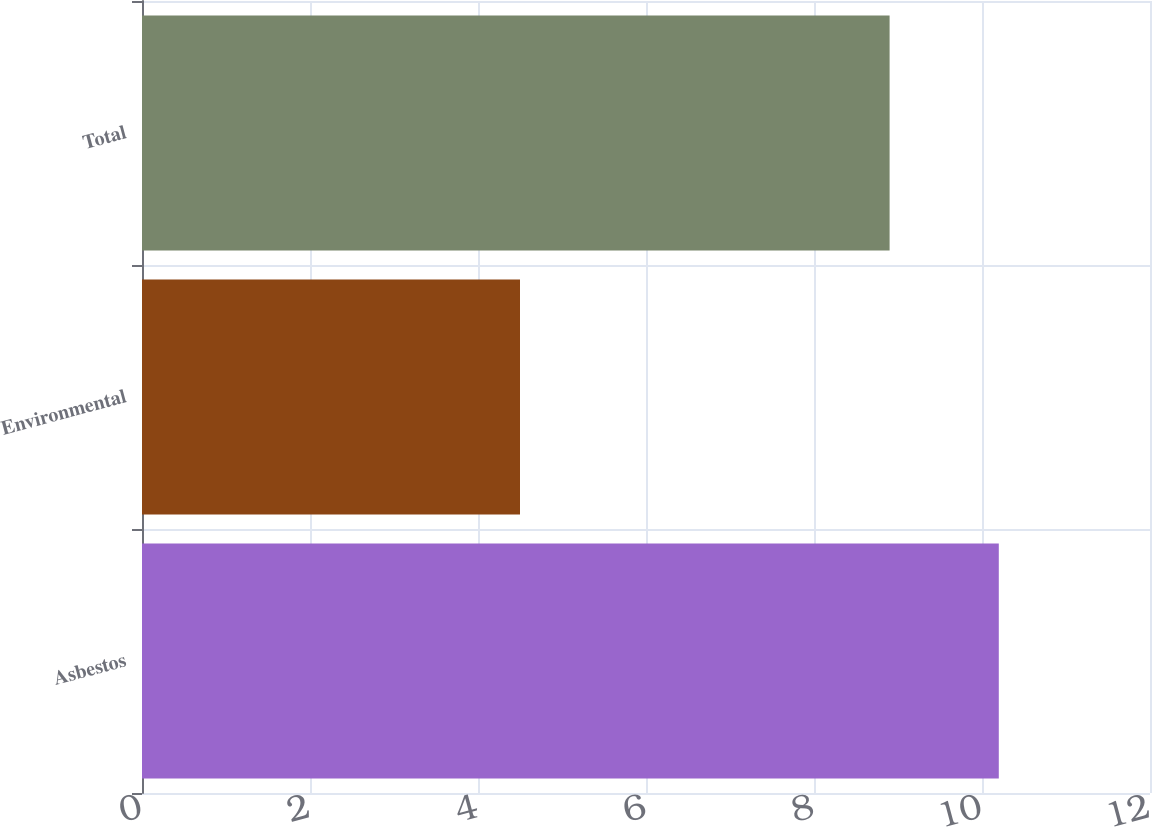<chart> <loc_0><loc_0><loc_500><loc_500><bar_chart><fcel>Asbestos<fcel>Environmental<fcel>Total<nl><fcel>10.2<fcel>4.5<fcel>8.9<nl></chart> 